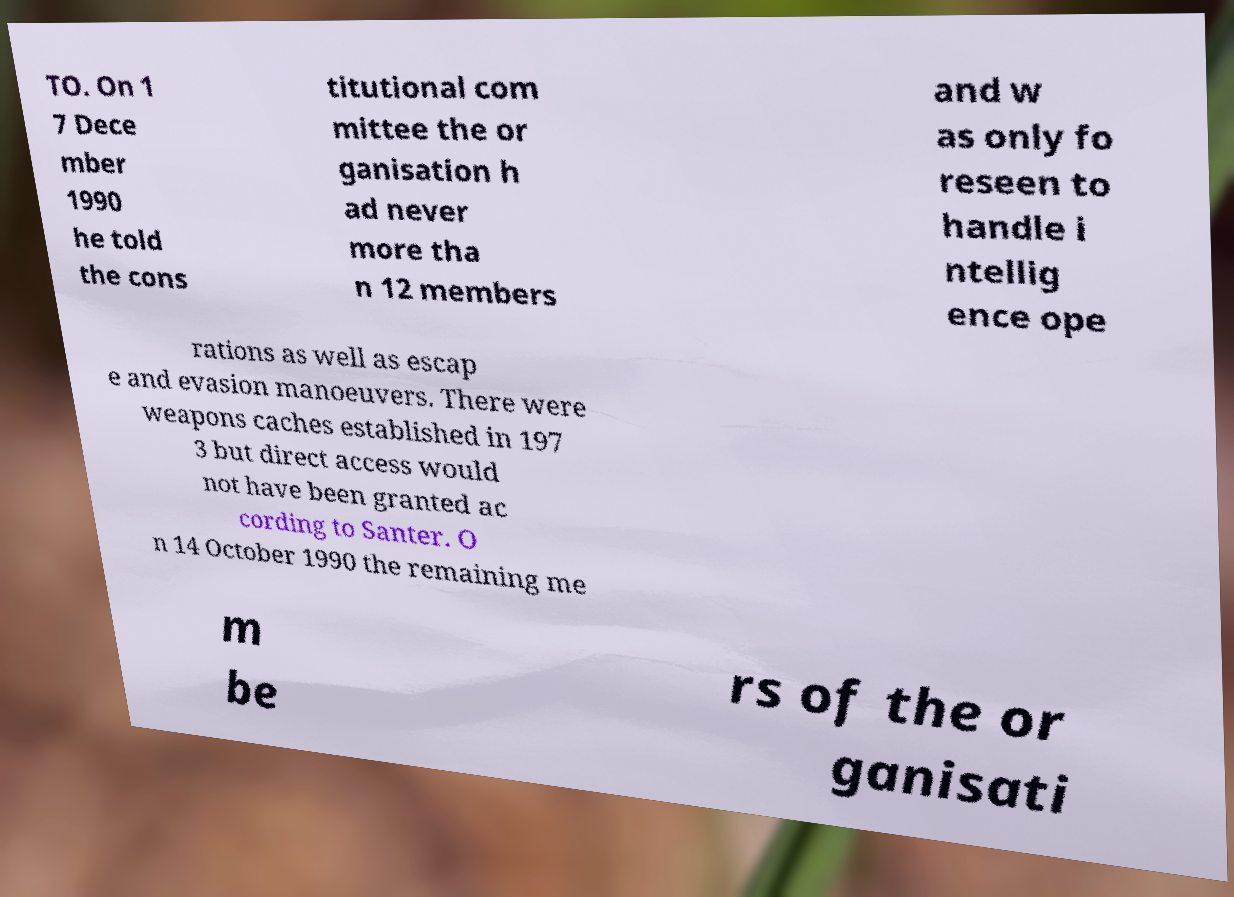Could you extract and type out the text from this image? TO. On 1 7 Dece mber 1990 he told the cons titutional com mittee the or ganisation h ad never more tha n 12 members and w as only fo reseen to handle i ntellig ence ope rations as well as escap e and evasion manoeuvers. There were weapons caches established in 197 3 but direct access would not have been granted ac cording to Santer. O n 14 October 1990 the remaining me m be rs of the or ganisati 